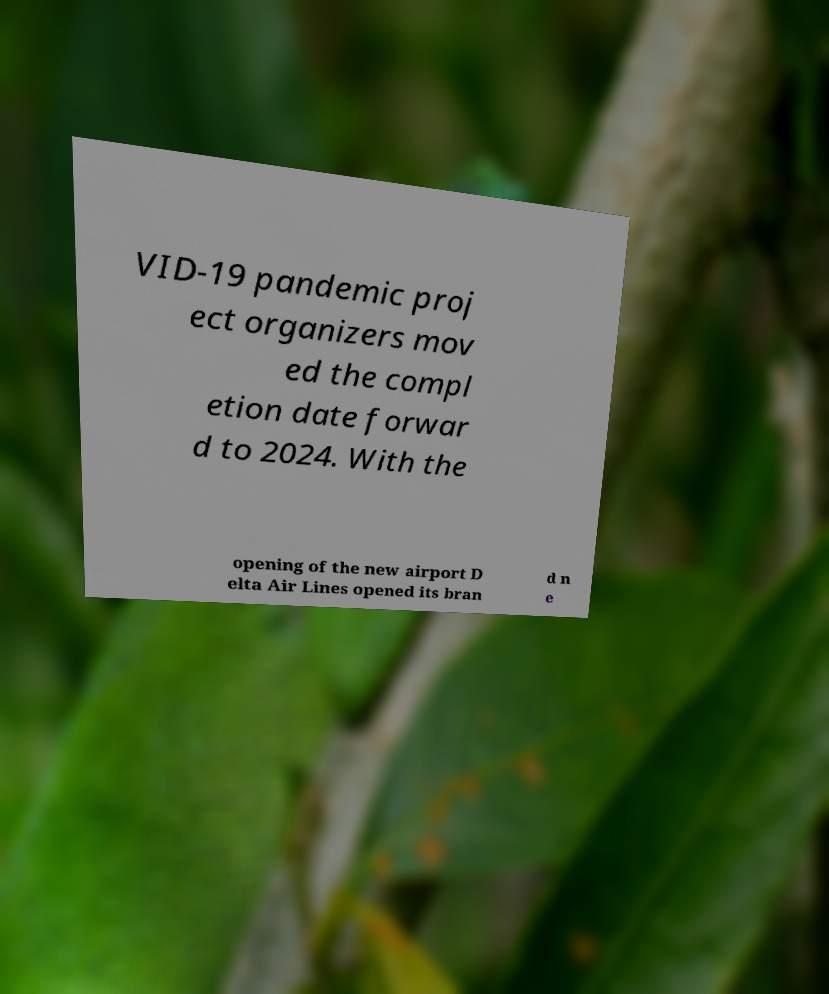Please read and relay the text visible in this image. What does it say? VID-19 pandemic proj ect organizers mov ed the compl etion date forwar d to 2024. With the opening of the new airport D elta Air Lines opened its bran d n e 